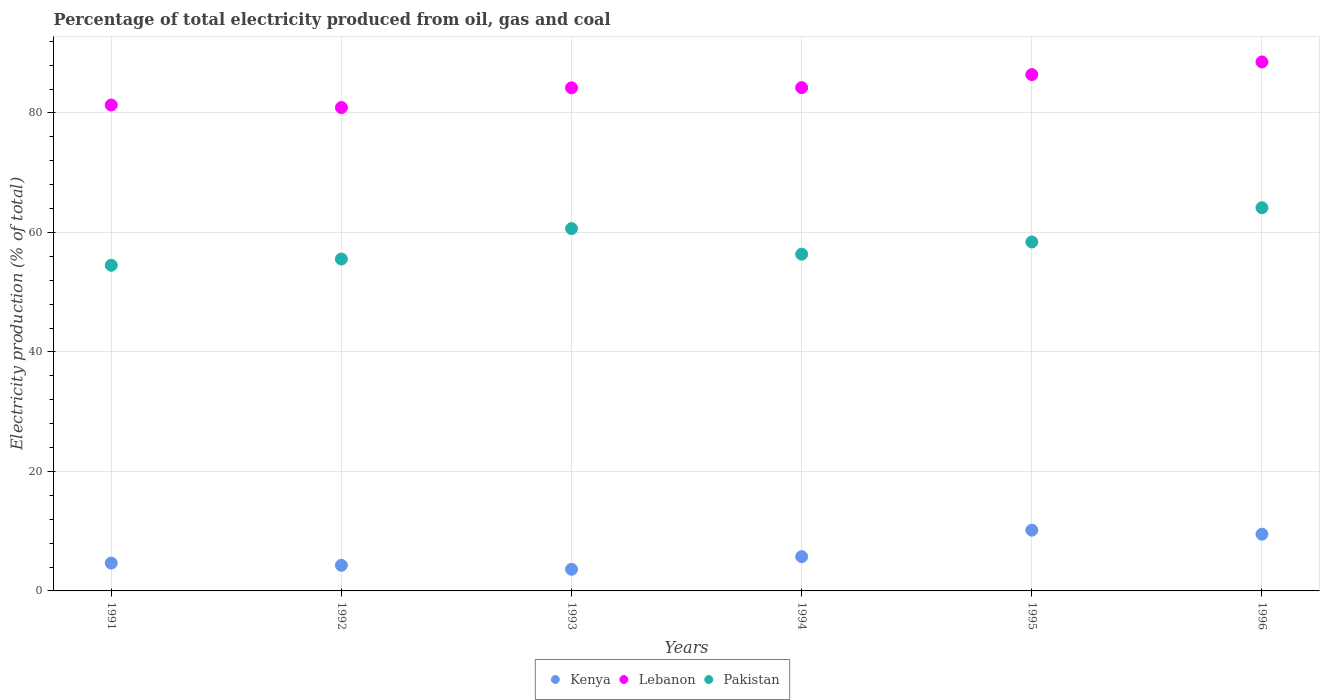How many different coloured dotlines are there?
Offer a terse response. 3. Is the number of dotlines equal to the number of legend labels?
Ensure brevity in your answer.  Yes. What is the electricity production in in Lebanon in 1995?
Offer a very short reply. 86.42. Across all years, what is the maximum electricity production in in Lebanon?
Keep it short and to the point. 88.54. Across all years, what is the minimum electricity production in in Pakistan?
Provide a succinct answer. 54.5. In which year was the electricity production in in Lebanon maximum?
Your answer should be very brief. 1996. In which year was the electricity production in in Lebanon minimum?
Give a very brief answer. 1992. What is the total electricity production in in Kenya in the graph?
Provide a succinct answer. 37.97. What is the difference between the electricity production in in Lebanon in 1992 and that in 1996?
Provide a succinct answer. -7.64. What is the difference between the electricity production in in Pakistan in 1993 and the electricity production in in Lebanon in 1991?
Provide a succinct answer. -20.69. What is the average electricity production in in Lebanon per year?
Your answer should be very brief. 84.28. In the year 1992, what is the difference between the electricity production in in Pakistan and electricity production in in Kenya?
Provide a short and direct response. 51.27. In how many years, is the electricity production in in Lebanon greater than 36 %?
Your response must be concise. 6. What is the ratio of the electricity production in in Lebanon in 1994 to that in 1996?
Give a very brief answer. 0.95. Is the electricity production in in Kenya in 1992 less than that in 1995?
Ensure brevity in your answer.  Yes. What is the difference between the highest and the second highest electricity production in in Pakistan?
Offer a terse response. 3.49. What is the difference between the highest and the lowest electricity production in in Pakistan?
Offer a very short reply. 9.63. Is the sum of the electricity production in in Pakistan in 1991 and 1996 greater than the maximum electricity production in in Lebanon across all years?
Provide a short and direct response. Yes. Is the electricity production in in Kenya strictly less than the electricity production in in Lebanon over the years?
Keep it short and to the point. Yes. How many dotlines are there?
Your response must be concise. 3. How many years are there in the graph?
Provide a succinct answer. 6. What is the difference between two consecutive major ticks on the Y-axis?
Your response must be concise. 20. Does the graph contain any zero values?
Your answer should be compact. No. What is the title of the graph?
Make the answer very short. Percentage of total electricity produced from oil, gas and coal. What is the label or title of the X-axis?
Offer a terse response. Years. What is the label or title of the Y-axis?
Make the answer very short. Electricity production (% of total). What is the Electricity production (% of total) in Kenya in 1991?
Your answer should be compact. 4.66. What is the Electricity production (% of total) of Lebanon in 1991?
Your response must be concise. 81.33. What is the Electricity production (% of total) of Pakistan in 1991?
Your answer should be very brief. 54.5. What is the Electricity production (% of total) of Kenya in 1992?
Keep it short and to the point. 4.29. What is the Electricity production (% of total) in Lebanon in 1992?
Provide a short and direct response. 80.91. What is the Electricity production (% of total) in Pakistan in 1992?
Ensure brevity in your answer.  55.55. What is the Electricity production (% of total) of Kenya in 1993?
Your answer should be very brief. 3.62. What is the Electricity production (% of total) in Lebanon in 1993?
Ensure brevity in your answer.  84.21. What is the Electricity production (% of total) of Pakistan in 1993?
Ensure brevity in your answer.  60.64. What is the Electricity production (% of total) of Kenya in 1994?
Keep it short and to the point. 5.74. What is the Electricity production (% of total) in Lebanon in 1994?
Give a very brief answer. 84.24. What is the Electricity production (% of total) in Pakistan in 1994?
Ensure brevity in your answer.  56.36. What is the Electricity production (% of total) in Kenya in 1995?
Make the answer very short. 10.17. What is the Electricity production (% of total) of Lebanon in 1995?
Give a very brief answer. 86.42. What is the Electricity production (% of total) of Pakistan in 1995?
Your response must be concise. 58.41. What is the Electricity production (% of total) in Kenya in 1996?
Your answer should be very brief. 9.5. What is the Electricity production (% of total) in Lebanon in 1996?
Offer a very short reply. 88.54. What is the Electricity production (% of total) in Pakistan in 1996?
Provide a short and direct response. 64.14. Across all years, what is the maximum Electricity production (% of total) of Kenya?
Your response must be concise. 10.17. Across all years, what is the maximum Electricity production (% of total) of Lebanon?
Give a very brief answer. 88.54. Across all years, what is the maximum Electricity production (% of total) in Pakistan?
Offer a very short reply. 64.14. Across all years, what is the minimum Electricity production (% of total) in Kenya?
Give a very brief answer. 3.62. Across all years, what is the minimum Electricity production (% of total) of Lebanon?
Give a very brief answer. 80.91. Across all years, what is the minimum Electricity production (% of total) of Pakistan?
Your answer should be compact. 54.5. What is the total Electricity production (% of total) of Kenya in the graph?
Ensure brevity in your answer.  37.97. What is the total Electricity production (% of total) of Lebanon in the graph?
Your answer should be very brief. 505.66. What is the total Electricity production (% of total) in Pakistan in the graph?
Your answer should be very brief. 349.61. What is the difference between the Electricity production (% of total) of Kenya in 1991 and that in 1992?
Your response must be concise. 0.37. What is the difference between the Electricity production (% of total) in Lebanon in 1991 and that in 1992?
Your answer should be compact. 0.43. What is the difference between the Electricity production (% of total) in Pakistan in 1991 and that in 1992?
Offer a terse response. -1.05. What is the difference between the Electricity production (% of total) in Kenya in 1991 and that in 1993?
Provide a short and direct response. 1.04. What is the difference between the Electricity production (% of total) in Lebanon in 1991 and that in 1993?
Ensure brevity in your answer.  -2.88. What is the difference between the Electricity production (% of total) of Pakistan in 1991 and that in 1993?
Provide a short and direct response. -6.14. What is the difference between the Electricity production (% of total) in Kenya in 1991 and that in 1994?
Your response must be concise. -1.08. What is the difference between the Electricity production (% of total) of Lebanon in 1991 and that in 1994?
Your answer should be compact. -2.91. What is the difference between the Electricity production (% of total) in Pakistan in 1991 and that in 1994?
Ensure brevity in your answer.  -1.86. What is the difference between the Electricity production (% of total) in Kenya in 1991 and that in 1995?
Give a very brief answer. -5.51. What is the difference between the Electricity production (% of total) in Lebanon in 1991 and that in 1995?
Your response must be concise. -5.09. What is the difference between the Electricity production (% of total) in Pakistan in 1991 and that in 1995?
Keep it short and to the point. -3.91. What is the difference between the Electricity production (% of total) of Kenya in 1991 and that in 1996?
Keep it short and to the point. -4.84. What is the difference between the Electricity production (% of total) in Lebanon in 1991 and that in 1996?
Offer a terse response. -7.21. What is the difference between the Electricity production (% of total) in Pakistan in 1991 and that in 1996?
Give a very brief answer. -9.63. What is the difference between the Electricity production (% of total) in Kenya in 1992 and that in 1993?
Your answer should be very brief. 0.66. What is the difference between the Electricity production (% of total) in Lebanon in 1992 and that in 1993?
Give a very brief answer. -3.3. What is the difference between the Electricity production (% of total) of Pakistan in 1992 and that in 1993?
Your answer should be very brief. -5.09. What is the difference between the Electricity production (% of total) of Kenya in 1992 and that in 1994?
Offer a terse response. -1.45. What is the difference between the Electricity production (% of total) in Lebanon in 1992 and that in 1994?
Ensure brevity in your answer.  -3.33. What is the difference between the Electricity production (% of total) in Pakistan in 1992 and that in 1994?
Ensure brevity in your answer.  -0.81. What is the difference between the Electricity production (% of total) of Kenya in 1992 and that in 1995?
Give a very brief answer. -5.88. What is the difference between the Electricity production (% of total) in Lebanon in 1992 and that in 1995?
Ensure brevity in your answer.  -5.52. What is the difference between the Electricity production (% of total) in Pakistan in 1992 and that in 1995?
Ensure brevity in your answer.  -2.85. What is the difference between the Electricity production (% of total) in Kenya in 1992 and that in 1996?
Offer a terse response. -5.21. What is the difference between the Electricity production (% of total) in Lebanon in 1992 and that in 1996?
Make the answer very short. -7.64. What is the difference between the Electricity production (% of total) in Pakistan in 1992 and that in 1996?
Give a very brief answer. -8.58. What is the difference between the Electricity production (% of total) of Kenya in 1993 and that in 1994?
Keep it short and to the point. -2.11. What is the difference between the Electricity production (% of total) of Lebanon in 1993 and that in 1994?
Offer a very short reply. -0.03. What is the difference between the Electricity production (% of total) of Pakistan in 1993 and that in 1994?
Offer a very short reply. 4.28. What is the difference between the Electricity production (% of total) of Kenya in 1993 and that in 1995?
Ensure brevity in your answer.  -6.55. What is the difference between the Electricity production (% of total) of Lebanon in 1993 and that in 1995?
Your answer should be compact. -2.21. What is the difference between the Electricity production (% of total) of Pakistan in 1993 and that in 1995?
Provide a succinct answer. 2.23. What is the difference between the Electricity production (% of total) in Kenya in 1993 and that in 1996?
Provide a short and direct response. -5.87. What is the difference between the Electricity production (% of total) of Lebanon in 1993 and that in 1996?
Make the answer very short. -4.33. What is the difference between the Electricity production (% of total) in Pakistan in 1993 and that in 1996?
Provide a succinct answer. -3.49. What is the difference between the Electricity production (% of total) in Kenya in 1994 and that in 1995?
Your answer should be compact. -4.43. What is the difference between the Electricity production (% of total) in Lebanon in 1994 and that in 1995?
Make the answer very short. -2.18. What is the difference between the Electricity production (% of total) in Pakistan in 1994 and that in 1995?
Provide a succinct answer. -2.04. What is the difference between the Electricity production (% of total) in Kenya in 1994 and that in 1996?
Ensure brevity in your answer.  -3.76. What is the difference between the Electricity production (% of total) in Lebanon in 1994 and that in 1996?
Your response must be concise. -4.3. What is the difference between the Electricity production (% of total) of Pakistan in 1994 and that in 1996?
Provide a short and direct response. -7.77. What is the difference between the Electricity production (% of total) in Kenya in 1995 and that in 1996?
Give a very brief answer. 0.67. What is the difference between the Electricity production (% of total) of Lebanon in 1995 and that in 1996?
Offer a very short reply. -2.12. What is the difference between the Electricity production (% of total) in Pakistan in 1995 and that in 1996?
Your answer should be compact. -5.73. What is the difference between the Electricity production (% of total) of Kenya in 1991 and the Electricity production (% of total) of Lebanon in 1992?
Your answer should be compact. -76.25. What is the difference between the Electricity production (% of total) in Kenya in 1991 and the Electricity production (% of total) in Pakistan in 1992?
Your answer should be compact. -50.89. What is the difference between the Electricity production (% of total) of Lebanon in 1991 and the Electricity production (% of total) of Pakistan in 1992?
Your answer should be very brief. 25.78. What is the difference between the Electricity production (% of total) in Kenya in 1991 and the Electricity production (% of total) in Lebanon in 1993?
Offer a terse response. -79.55. What is the difference between the Electricity production (% of total) of Kenya in 1991 and the Electricity production (% of total) of Pakistan in 1993?
Your answer should be compact. -55.98. What is the difference between the Electricity production (% of total) in Lebanon in 1991 and the Electricity production (% of total) in Pakistan in 1993?
Offer a very short reply. 20.69. What is the difference between the Electricity production (% of total) in Kenya in 1991 and the Electricity production (% of total) in Lebanon in 1994?
Keep it short and to the point. -79.58. What is the difference between the Electricity production (% of total) of Kenya in 1991 and the Electricity production (% of total) of Pakistan in 1994?
Keep it short and to the point. -51.71. What is the difference between the Electricity production (% of total) in Lebanon in 1991 and the Electricity production (% of total) in Pakistan in 1994?
Give a very brief answer. 24.97. What is the difference between the Electricity production (% of total) in Kenya in 1991 and the Electricity production (% of total) in Lebanon in 1995?
Give a very brief answer. -81.76. What is the difference between the Electricity production (% of total) of Kenya in 1991 and the Electricity production (% of total) of Pakistan in 1995?
Keep it short and to the point. -53.75. What is the difference between the Electricity production (% of total) in Lebanon in 1991 and the Electricity production (% of total) in Pakistan in 1995?
Your response must be concise. 22.92. What is the difference between the Electricity production (% of total) of Kenya in 1991 and the Electricity production (% of total) of Lebanon in 1996?
Give a very brief answer. -83.88. What is the difference between the Electricity production (% of total) of Kenya in 1991 and the Electricity production (% of total) of Pakistan in 1996?
Your response must be concise. -59.48. What is the difference between the Electricity production (% of total) of Lebanon in 1991 and the Electricity production (% of total) of Pakistan in 1996?
Ensure brevity in your answer.  17.2. What is the difference between the Electricity production (% of total) of Kenya in 1992 and the Electricity production (% of total) of Lebanon in 1993?
Provide a short and direct response. -79.92. What is the difference between the Electricity production (% of total) in Kenya in 1992 and the Electricity production (% of total) in Pakistan in 1993?
Ensure brevity in your answer.  -56.36. What is the difference between the Electricity production (% of total) of Lebanon in 1992 and the Electricity production (% of total) of Pakistan in 1993?
Keep it short and to the point. 20.26. What is the difference between the Electricity production (% of total) of Kenya in 1992 and the Electricity production (% of total) of Lebanon in 1994?
Offer a very short reply. -79.95. What is the difference between the Electricity production (% of total) of Kenya in 1992 and the Electricity production (% of total) of Pakistan in 1994?
Provide a short and direct response. -52.08. What is the difference between the Electricity production (% of total) in Lebanon in 1992 and the Electricity production (% of total) in Pakistan in 1994?
Give a very brief answer. 24.54. What is the difference between the Electricity production (% of total) of Kenya in 1992 and the Electricity production (% of total) of Lebanon in 1995?
Ensure brevity in your answer.  -82.14. What is the difference between the Electricity production (% of total) in Kenya in 1992 and the Electricity production (% of total) in Pakistan in 1995?
Give a very brief answer. -54.12. What is the difference between the Electricity production (% of total) in Lebanon in 1992 and the Electricity production (% of total) in Pakistan in 1995?
Keep it short and to the point. 22.5. What is the difference between the Electricity production (% of total) in Kenya in 1992 and the Electricity production (% of total) in Lebanon in 1996?
Make the answer very short. -84.26. What is the difference between the Electricity production (% of total) in Kenya in 1992 and the Electricity production (% of total) in Pakistan in 1996?
Your answer should be compact. -59.85. What is the difference between the Electricity production (% of total) of Lebanon in 1992 and the Electricity production (% of total) of Pakistan in 1996?
Offer a terse response. 16.77. What is the difference between the Electricity production (% of total) in Kenya in 1993 and the Electricity production (% of total) in Lebanon in 1994?
Your answer should be very brief. -80.62. What is the difference between the Electricity production (% of total) in Kenya in 1993 and the Electricity production (% of total) in Pakistan in 1994?
Offer a very short reply. -52.74. What is the difference between the Electricity production (% of total) in Lebanon in 1993 and the Electricity production (% of total) in Pakistan in 1994?
Your response must be concise. 27.85. What is the difference between the Electricity production (% of total) of Kenya in 1993 and the Electricity production (% of total) of Lebanon in 1995?
Make the answer very short. -82.8. What is the difference between the Electricity production (% of total) in Kenya in 1993 and the Electricity production (% of total) in Pakistan in 1995?
Ensure brevity in your answer.  -54.79. What is the difference between the Electricity production (% of total) in Lebanon in 1993 and the Electricity production (% of total) in Pakistan in 1995?
Ensure brevity in your answer.  25.8. What is the difference between the Electricity production (% of total) in Kenya in 1993 and the Electricity production (% of total) in Lebanon in 1996?
Provide a succinct answer. -84.92. What is the difference between the Electricity production (% of total) of Kenya in 1993 and the Electricity production (% of total) of Pakistan in 1996?
Your answer should be very brief. -60.51. What is the difference between the Electricity production (% of total) in Lebanon in 1993 and the Electricity production (% of total) in Pakistan in 1996?
Give a very brief answer. 20.07. What is the difference between the Electricity production (% of total) in Kenya in 1994 and the Electricity production (% of total) in Lebanon in 1995?
Offer a terse response. -80.69. What is the difference between the Electricity production (% of total) of Kenya in 1994 and the Electricity production (% of total) of Pakistan in 1995?
Provide a succinct answer. -52.67. What is the difference between the Electricity production (% of total) of Lebanon in 1994 and the Electricity production (% of total) of Pakistan in 1995?
Your answer should be very brief. 25.83. What is the difference between the Electricity production (% of total) in Kenya in 1994 and the Electricity production (% of total) in Lebanon in 1996?
Keep it short and to the point. -82.81. What is the difference between the Electricity production (% of total) of Kenya in 1994 and the Electricity production (% of total) of Pakistan in 1996?
Your answer should be compact. -58.4. What is the difference between the Electricity production (% of total) of Lebanon in 1994 and the Electricity production (% of total) of Pakistan in 1996?
Your answer should be compact. 20.1. What is the difference between the Electricity production (% of total) of Kenya in 1995 and the Electricity production (% of total) of Lebanon in 1996?
Offer a very short reply. -78.37. What is the difference between the Electricity production (% of total) of Kenya in 1995 and the Electricity production (% of total) of Pakistan in 1996?
Keep it short and to the point. -53.97. What is the difference between the Electricity production (% of total) in Lebanon in 1995 and the Electricity production (% of total) in Pakistan in 1996?
Keep it short and to the point. 22.29. What is the average Electricity production (% of total) in Kenya per year?
Your response must be concise. 6.33. What is the average Electricity production (% of total) in Lebanon per year?
Offer a very short reply. 84.28. What is the average Electricity production (% of total) in Pakistan per year?
Offer a terse response. 58.27. In the year 1991, what is the difference between the Electricity production (% of total) in Kenya and Electricity production (% of total) in Lebanon?
Offer a very short reply. -76.67. In the year 1991, what is the difference between the Electricity production (% of total) in Kenya and Electricity production (% of total) in Pakistan?
Your response must be concise. -49.84. In the year 1991, what is the difference between the Electricity production (% of total) in Lebanon and Electricity production (% of total) in Pakistan?
Give a very brief answer. 26.83. In the year 1992, what is the difference between the Electricity production (% of total) of Kenya and Electricity production (% of total) of Lebanon?
Your answer should be very brief. -76.62. In the year 1992, what is the difference between the Electricity production (% of total) in Kenya and Electricity production (% of total) in Pakistan?
Make the answer very short. -51.27. In the year 1992, what is the difference between the Electricity production (% of total) in Lebanon and Electricity production (% of total) in Pakistan?
Your answer should be compact. 25.35. In the year 1993, what is the difference between the Electricity production (% of total) in Kenya and Electricity production (% of total) in Lebanon?
Offer a terse response. -80.59. In the year 1993, what is the difference between the Electricity production (% of total) of Kenya and Electricity production (% of total) of Pakistan?
Provide a succinct answer. -57.02. In the year 1993, what is the difference between the Electricity production (% of total) of Lebanon and Electricity production (% of total) of Pakistan?
Provide a succinct answer. 23.57. In the year 1994, what is the difference between the Electricity production (% of total) in Kenya and Electricity production (% of total) in Lebanon?
Ensure brevity in your answer.  -78.5. In the year 1994, what is the difference between the Electricity production (% of total) in Kenya and Electricity production (% of total) in Pakistan?
Your answer should be very brief. -50.63. In the year 1994, what is the difference between the Electricity production (% of total) in Lebanon and Electricity production (% of total) in Pakistan?
Your response must be concise. 27.88. In the year 1995, what is the difference between the Electricity production (% of total) in Kenya and Electricity production (% of total) in Lebanon?
Ensure brevity in your answer.  -76.25. In the year 1995, what is the difference between the Electricity production (% of total) of Kenya and Electricity production (% of total) of Pakistan?
Ensure brevity in your answer.  -48.24. In the year 1995, what is the difference between the Electricity production (% of total) of Lebanon and Electricity production (% of total) of Pakistan?
Your response must be concise. 28.01. In the year 1996, what is the difference between the Electricity production (% of total) of Kenya and Electricity production (% of total) of Lebanon?
Provide a short and direct response. -79.05. In the year 1996, what is the difference between the Electricity production (% of total) in Kenya and Electricity production (% of total) in Pakistan?
Your response must be concise. -54.64. In the year 1996, what is the difference between the Electricity production (% of total) of Lebanon and Electricity production (% of total) of Pakistan?
Offer a very short reply. 24.41. What is the ratio of the Electricity production (% of total) in Kenya in 1991 to that in 1992?
Give a very brief answer. 1.09. What is the ratio of the Electricity production (% of total) of Pakistan in 1991 to that in 1992?
Provide a succinct answer. 0.98. What is the ratio of the Electricity production (% of total) of Kenya in 1991 to that in 1993?
Offer a very short reply. 1.29. What is the ratio of the Electricity production (% of total) in Lebanon in 1991 to that in 1993?
Your answer should be very brief. 0.97. What is the ratio of the Electricity production (% of total) in Pakistan in 1991 to that in 1993?
Give a very brief answer. 0.9. What is the ratio of the Electricity production (% of total) in Kenya in 1991 to that in 1994?
Offer a very short reply. 0.81. What is the ratio of the Electricity production (% of total) in Lebanon in 1991 to that in 1994?
Ensure brevity in your answer.  0.97. What is the ratio of the Electricity production (% of total) of Pakistan in 1991 to that in 1994?
Provide a succinct answer. 0.97. What is the ratio of the Electricity production (% of total) in Kenya in 1991 to that in 1995?
Offer a very short reply. 0.46. What is the ratio of the Electricity production (% of total) of Lebanon in 1991 to that in 1995?
Offer a terse response. 0.94. What is the ratio of the Electricity production (% of total) in Pakistan in 1991 to that in 1995?
Make the answer very short. 0.93. What is the ratio of the Electricity production (% of total) in Kenya in 1991 to that in 1996?
Your answer should be compact. 0.49. What is the ratio of the Electricity production (% of total) of Lebanon in 1991 to that in 1996?
Ensure brevity in your answer.  0.92. What is the ratio of the Electricity production (% of total) in Pakistan in 1991 to that in 1996?
Provide a short and direct response. 0.85. What is the ratio of the Electricity production (% of total) in Kenya in 1992 to that in 1993?
Provide a short and direct response. 1.18. What is the ratio of the Electricity production (% of total) of Lebanon in 1992 to that in 1993?
Your answer should be very brief. 0.96. What is the ratio of the Electricity production (% of total) in Pakistan in 1992 to that in 1993?
Provide a short and direct response. 0.92. What is the ratio of the Electricity production (% of total) of Kenya in 1992 to that in 1994?
Give a very brief answer. 0.75. What is the ratio of the Electricity production (% of total) in Lebanon in 1992 to that in 1994?
Keep it short and to the point. 0.96. What is the ratio of the Electricity production (% of total) of Pakistan in 1992 to that in 1994?
Offer a very short reply. 0.99. What is the ratio of the Electricity production (% of total) of Kenya in 1992 to that in 1995?
Keep it short and to the point. 0.42. What is the ratio of the Electricity production (% of total) in Lebanon in 1992 to that in 1995?
Offer a terse response. 0.94. What is the ratio of the Electricity production (% of total) in Pakistan in 1992 to that in 1995?
Provide a succinct answer. 0.95. What is the ratio of the Electricity production (% of total) in Kenya in 1992 to that in 1996?
Provide a short and direct response. 0.45. What is the ratio of the Electricity production (% of total) in Lebanon in 1992 to that in 1996?
Your response must be concise. 0.91. What is the ratio of the Electricity production (% of total) in Pakistan in 1992 to that in 1996?
Keep it short and to the point. 0.87. What is the ratio of the Electricity production (% of total) in Kenya in 1993 to that in 1994?
Provide a short and direct response. 0.63. What is the ratio of the Electricity production (% of total) in Lebanon in 1993 to that in 1994?
Your response must be concise. 1. What is the ratio of the Electricity production (% of total) of Pakistan in 1993 to that in 1994?
Your answer should be compact. 1.08. What is the ratio of the Electricity production (% of total) in Kenya in 1993 to that in 1995?
Offer a terse response. 0.36. What is the ratio of the Electricity production (% of total) in Lebanon in 1993 to that in 1995?
Make the answer very short. 0.97. What is the ratio of the Electricity production (% of total) in Pakistan in 1993 to that in 1995?
Keep it short and to the point. 1.04. What is the ratio of the Electricity production (% of total) in Kenya in 1993 to that in 1996?
Offer a terse response. 0.38. What is the ratio of the Electricity production (% of total) in Lebanon in 1993 to that in 1996?
Ensure brevity in your answer.  0.95. What is the ratio of the Electricity production (% of total) of Pakistan in 1993 to that in 1996?
Give a very brief answer. 0.95. What is the ratio of the Electricity production (% of total) in Kenya in 1994 to that in 1995?
Provide a succinct answer. 0.56. What is the ratio of the Electricity production (% of total) of Lebanon in 1994 to that in 1995?
Keep it short and to the point. 0.97. What is the ratio of the Electricity production (% of total) in Pakistan in 1994 to that in 1995?
Offer a terse response. 0.96. What is the ratio of the Electricity production (% of total) of Kenya in 1994 to that in 1996?
Make the answer very short. 0.6. What is the ratio of the Electricity production (% of total) in Lebanon in 1994 to that in 1996?
Offer a very short reply. 0.95. What is the ratio of the Electricity production (% of total) in Pakistan in 1994 to that in 1996?
Your answer should be very brief. 0.88. What is the ratio of the Electricity production (% of total) of Kenya in 1995 to that in 1996?
Your response must be concise. 1.07. What is the ratio of the Electricity production (% of total) in Lebanon in 1995 to that in 1996?
Your response must be concise. 0.98. What is the ratio of the Electricity production (% of total) in Pakistan in 1995 to that in 1996?
Your answer should be compact. 0.91. What is the difference between the highest and the second highest Electricity production (% of total) in Kenya?
Keep it short and to the point. 0.67. What is the difference between the highest and the second highest Electricity production (% of total) of Lebanon?
Provide a short and direct response. 2.12. What is the difference between the highest and the second highest Electricity production (% of total) of Pakistan?
Offer a very short reply. 3.49. What is the difference between the highest and the lowest Electricity production (% of total) of Kenya?
Provide a short and direct response. 6.55. What is the difference between the highest and the lowest Electricity production (% of total) in Lebanon?
Make the answer very short. 7.64. What is the difference between the highest and the lowest Electricity production (% of total) in Pakistan?
Provide a short and direct response. 9.63. 